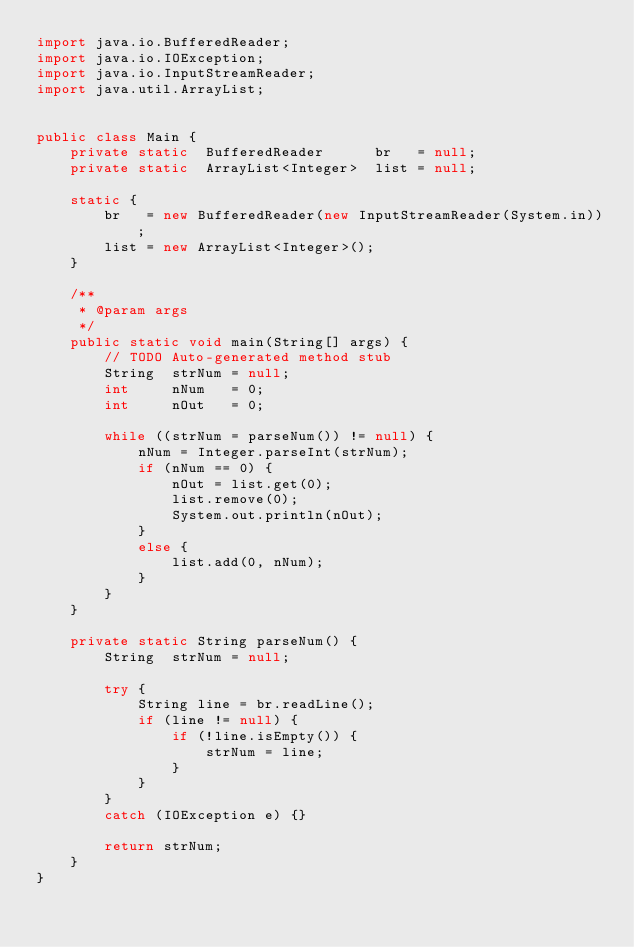<code> <loc_0><loc_0><loc_500><loc_500><_Java_>import java.io.BufferedReader;
import java.io.IOException;
import java.io.InputStreamReader;
import java.util.ArrayList;


public class Main {
	private	static	BufferedReader		br   = null;
	private	static	ArrayList<Integer>	list = null;

	static {
		br   = new BufferedReader(new InputStreamReader(System.in));
		list = new ArrayList<Integer>();
	}

	/**
	 * @param args
	 */
	public static void main(String[] args) {
		// TODO Auto-generated method stub
		String	strNum = null;
		int		nNum   = 0;
		int		nOut   = 0;

		while ((strNum = parseNum()) != null) {
			nNum = Integer.parseInt(strNum);
			if (nNum == 0) {
				nOut = list.get(0);
				list.remove(0);
				System.out.println(nOut);
			}
			else {
				list.add(0, nNum);
			}
		}
	}

	private static String parseNum() {
		String	strNum = null;

		try {
			String line = br.readLine();
			if (line != null) {
				if (!line.isEmpty()) {
					strNum = line;
				}
			}
		}
		catch (IOException e) {}

		return strNum;
	}
}</code> 